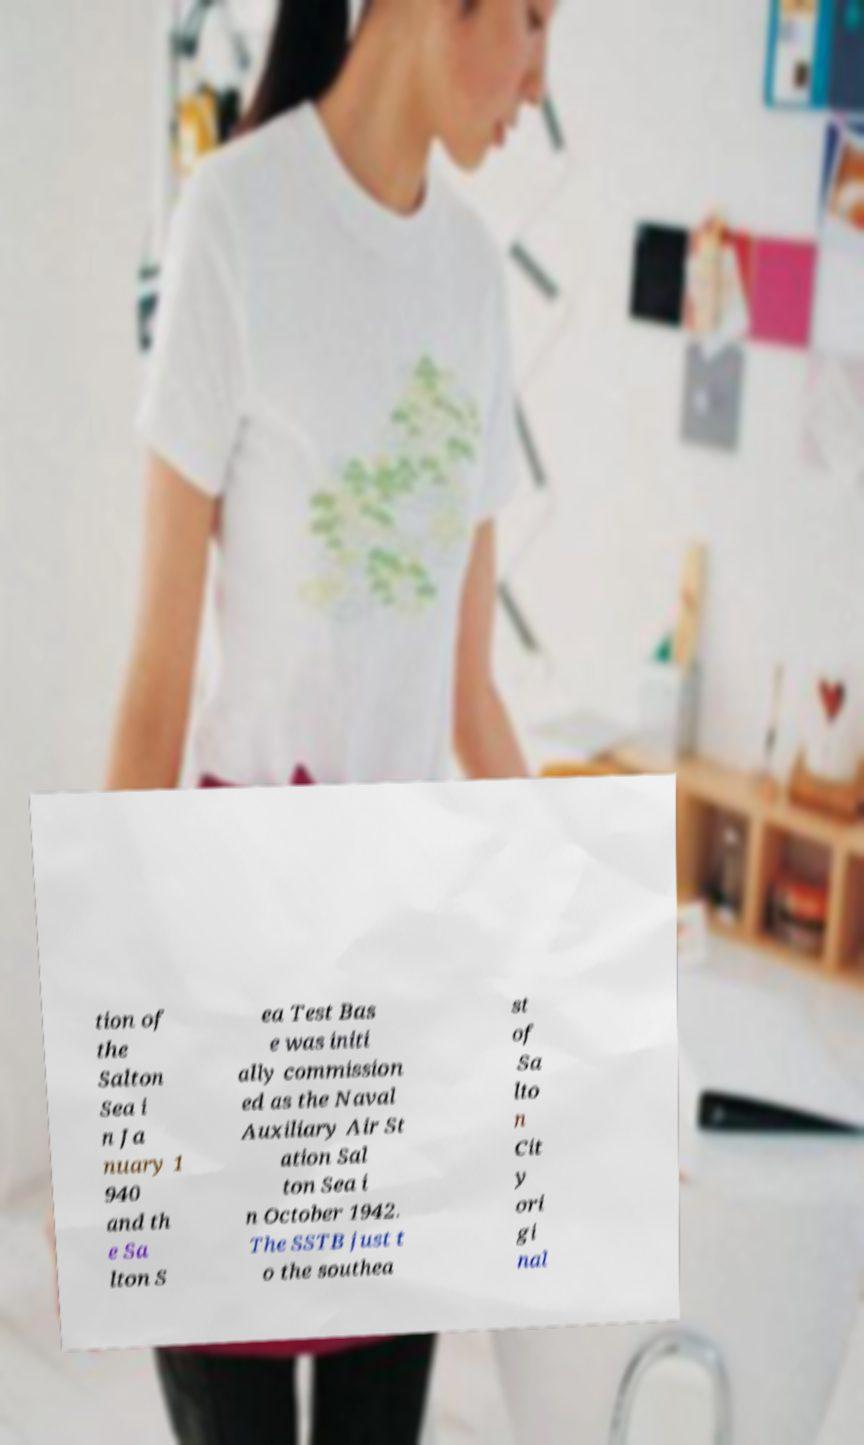For documentation purposes, I need the text within this image transcribed. Could you provide that? tion of the Salton Sea i n Ja nuary 1 940 and th e Sa lton S ea Test Bas e was initi ally commission ed as the Naval Auxiliary Air St ation Sal ton Sea i n October 1942. The SSTB just t o the southea st of Sa lto n Cit y ori gi nal 